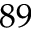<formula> <loc_0><loc_0><loc_500><loc_500>8 9</formula> 